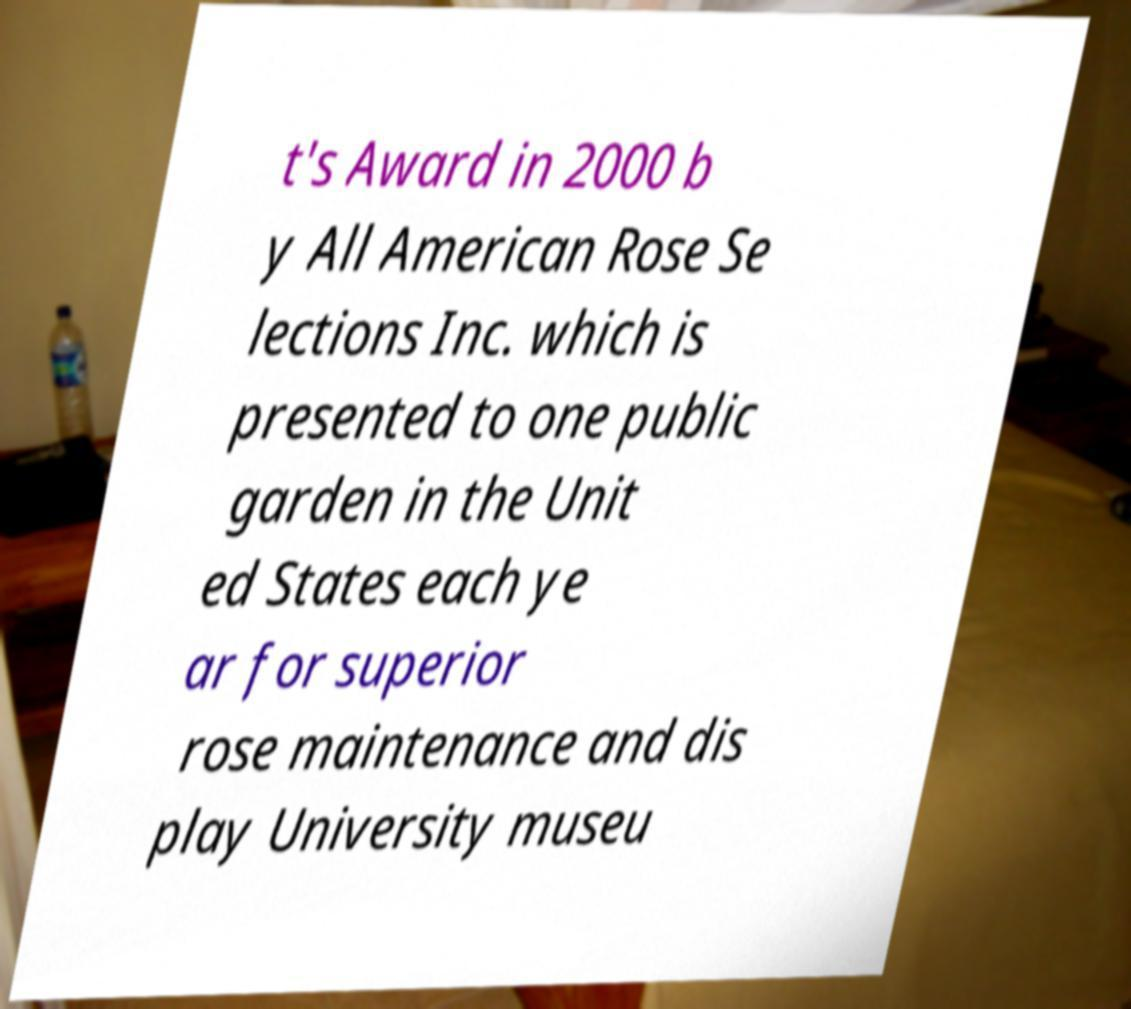Could you assist in decoding the text presented in this image and type it out clearly? t's Award in 2000 b y All American Rose Se lections Inc. which is presented to one public garden in the Unit ed States each ye ar for superior rose maintenance and dis play University museu 